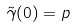<formula> <loc_0><loc_0><loc_500><loc_500>\tilde { \gamma } ( 0 ) = p</formula> 